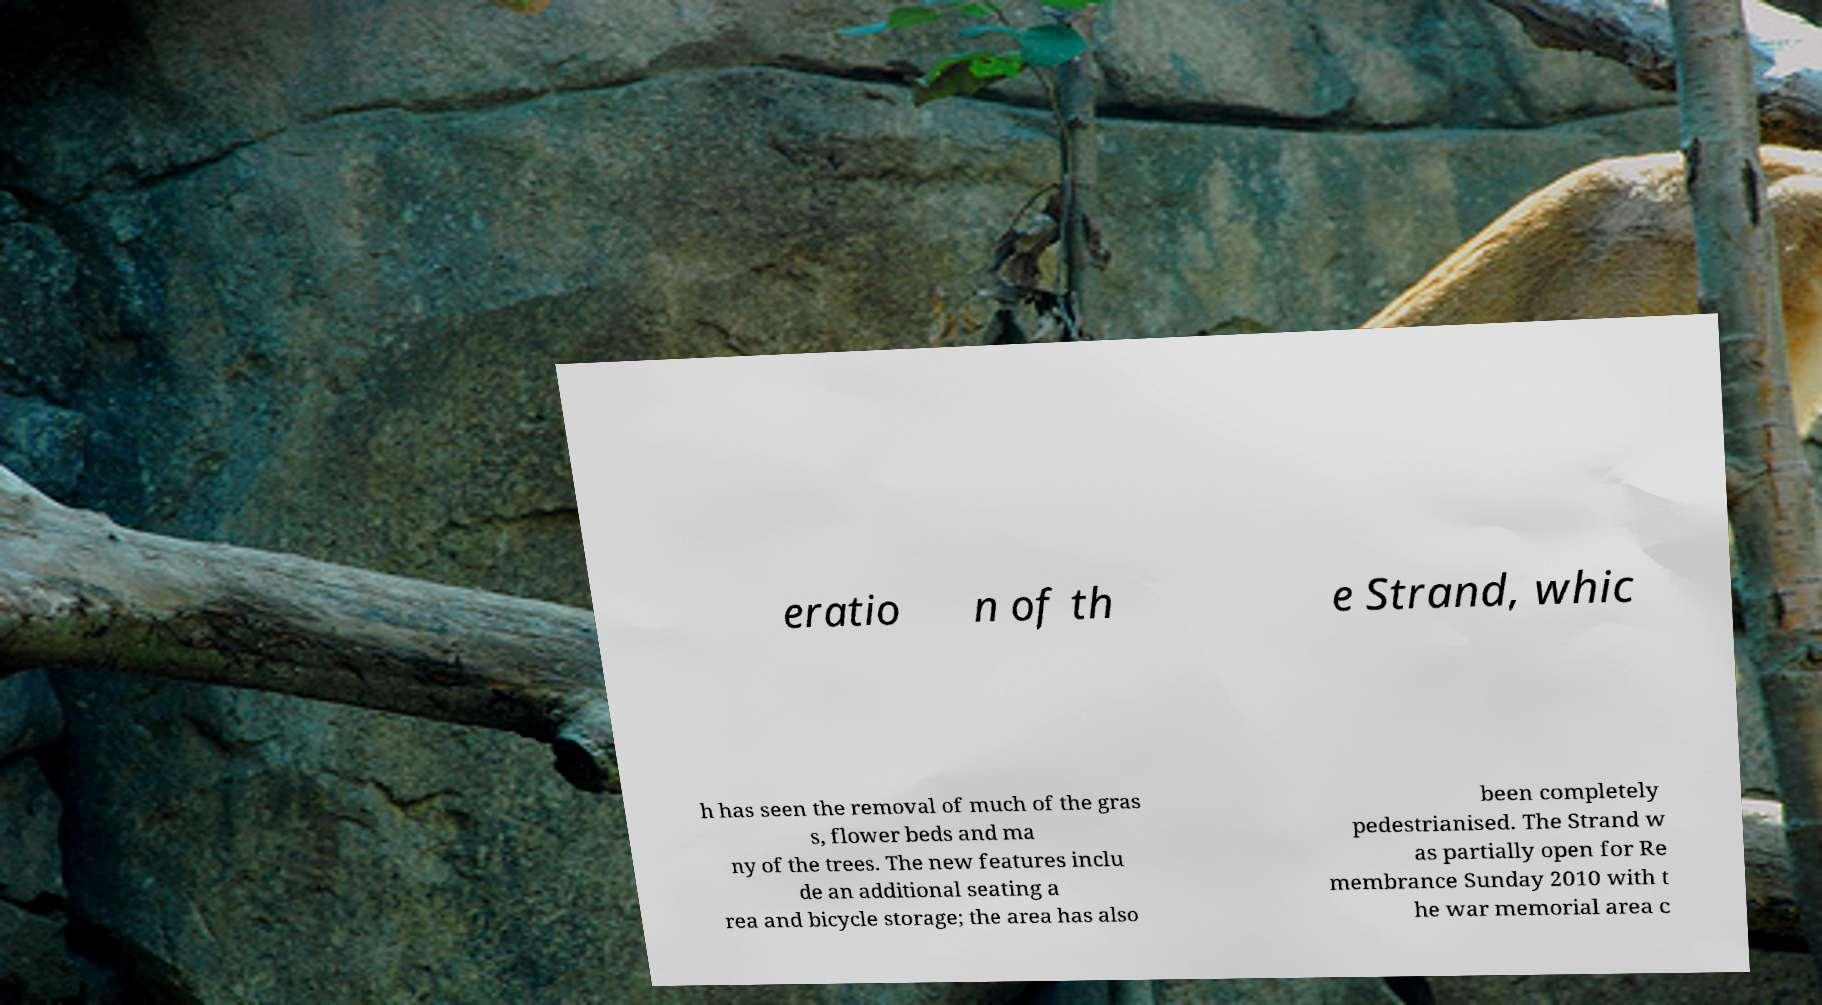Can you read and provide the text displayed in the image?This photo seems to have some interesting text. Can you extract and type it out for me? eratio n of th e Strand, whic h has seen the removal of much of the gras s, flower beds and ma ny of the trees. The new features inclu de an additional seating a rea and bicycle storage; the area has also been completely pedestrianised. The Strand w as partially open for Re membrance Sunday 2010 with t he war memorial area c 